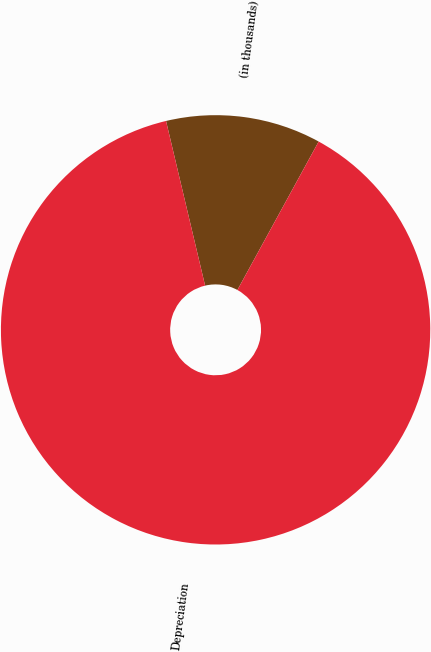Convert chart. <chart><loc_0><loc_0><loc_500><loc_500><pie_chart><fcel>(in thousands)<fcel>Depreciation<nl><fcel>11.68%<fcel>88.32%<nl></chart> 